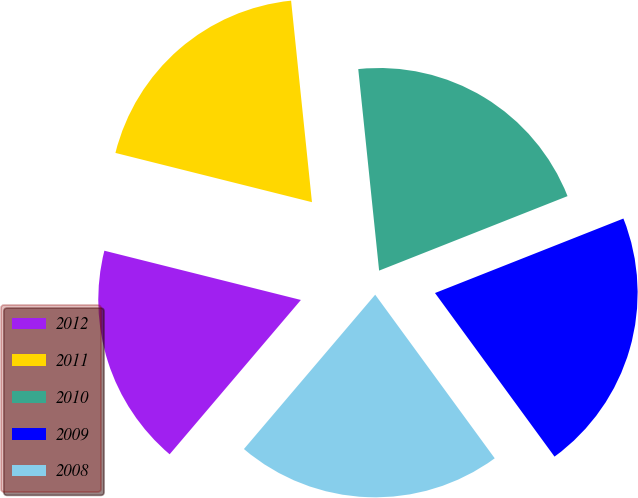Convert chart. <chart><loc_0><loc_0><loc_500><loc_500><pie_chart><fcel>2012<fcel>2011<fcel>2010<fcel>2009<fcel>2008<nl><fcel>17.69%<fcel>19.45%<fcel>20.65%<fcel>20.95%<fcel>21.26%<nl></chart> 